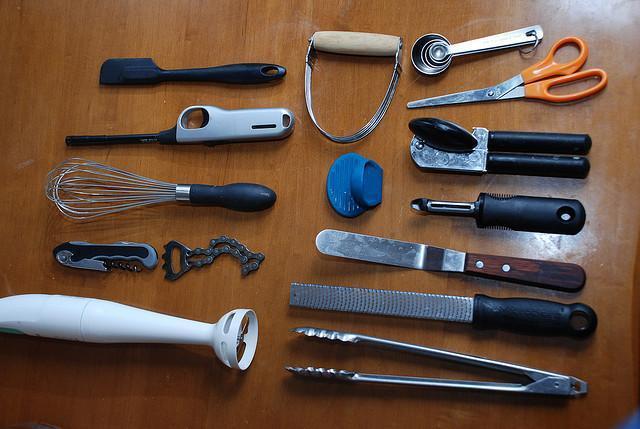How many scissors are in the photo?
Give a very brief answer. 1. How many cats are there?
Give a very brief answer. 0. 